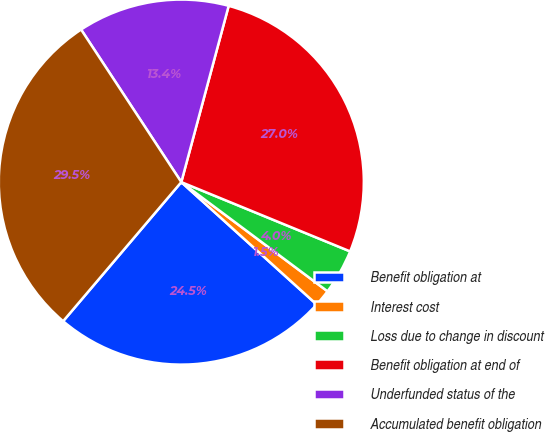Convert chart. <chart><loc_0><loc_0><loc_500><loc_500><pie_chart><fcel>Benefit obligation at<fcel>Interest cost<fcel>Loss due to change in discount<fcel>Benefit obligation at end of<fcel>Underfunded status of the<fcel>Accumulated benefit obligation<nl><fcel>24.51%<fcel>1.49%<fcel>4.01%<fcel>27.02%<fcel>13.43%<fcel>29.54%<nl></chart> 